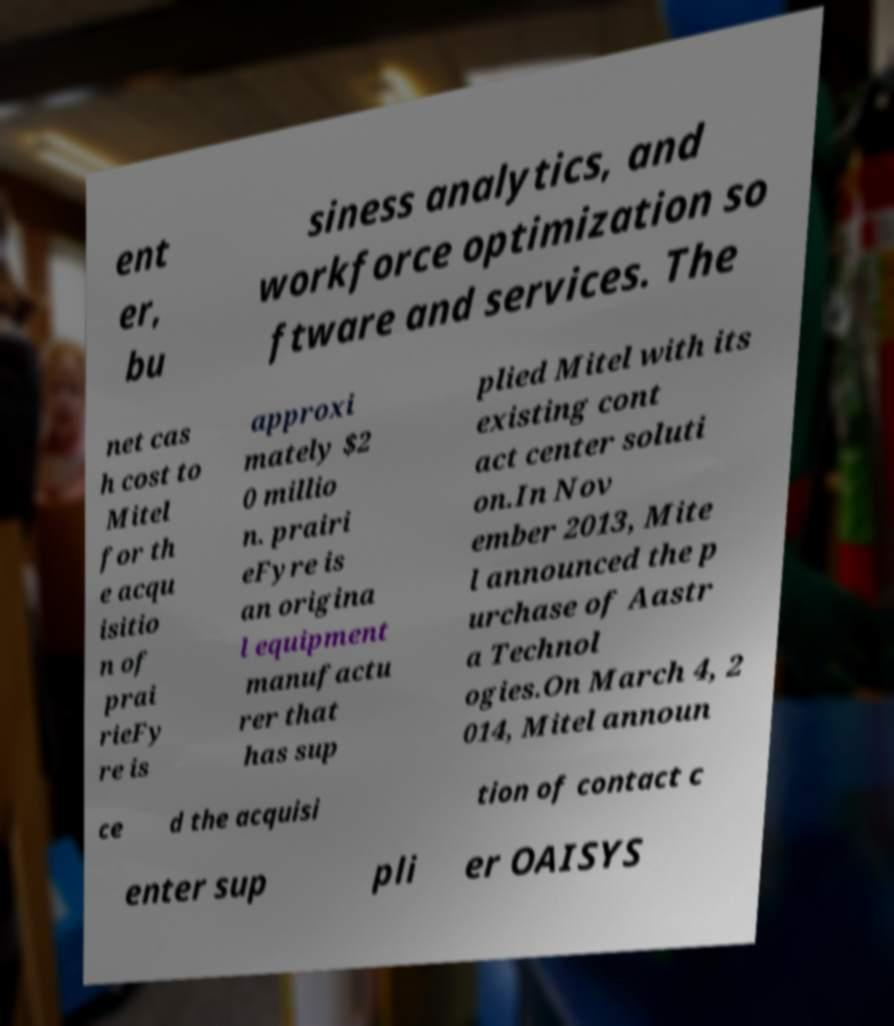Please read and relay the text visible in this image. What does it say? ent er, bu siness analytics, and workforce optimization so ftware and services. The net cas h cost to Mitel for th e acqu isitio n of prai rieFy re is approxi mately $2 0 millio n. prairi eFyre is an origina l equipment manufactu rer that has sup plied Mitel with its existing cont act center soluti on.In Nov ember 2013, Mite l announced the p urchase of Aastr a Technol ogies.On March 4, 2 014, Mitel announ ce d the acquisi tion of contact c enter sup pli er OAISYS 